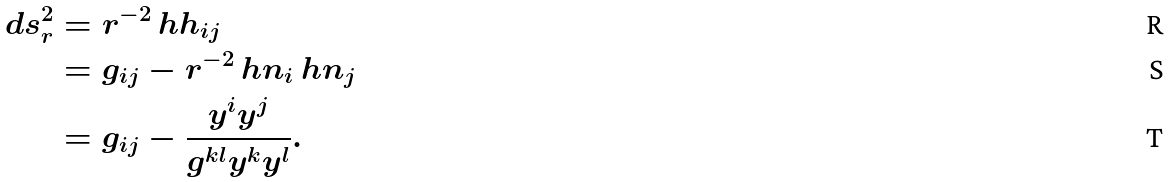<formula> <loc_0><loc_0><loc_500><loc_500>d s _ { r } ^ { 2 } & = r ^ { - 2 } \ h h _ { i j } \\ & = g _ { i j } - r ^ { - 2 } \ h n _ { i } \ h n _ { j } \\ & = g _ { i j } - \frac { y ^ { i } y ^ { j } } { g ^ { k l } y ^ { k } y ^ { l } } .</formula> 